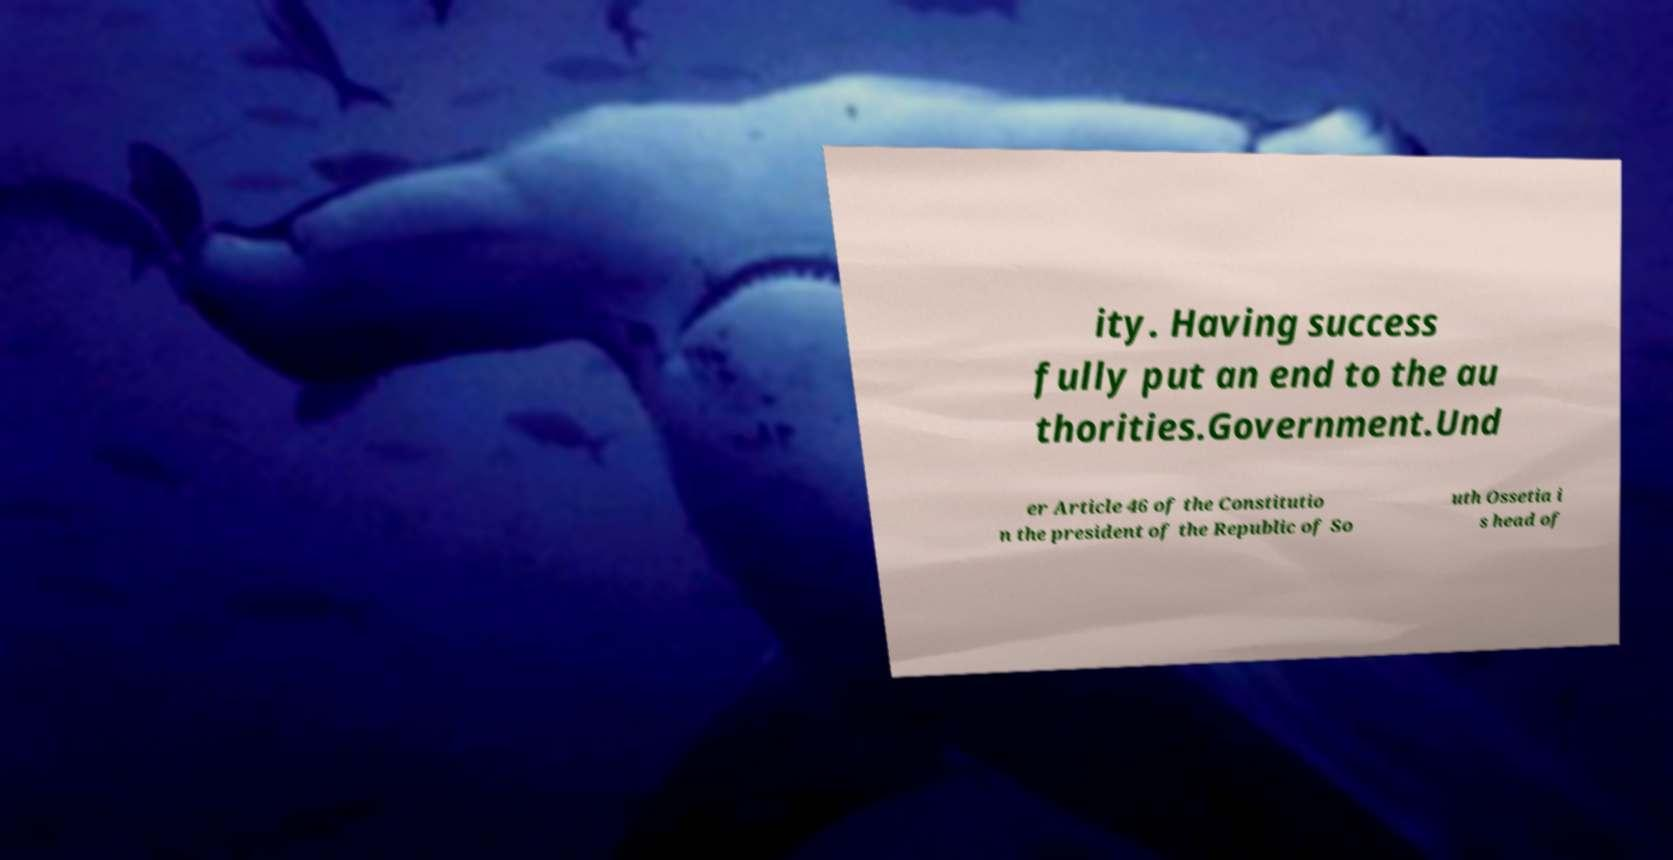Can you accurately transcribe the text from the provided image for me? ity. Having success fully put an end to the au thorities.Government.Und er Article 46 of the Constitutio n the president of the Republic of So uth Ossetia i s head of 